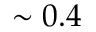Convert formula to latex. <formula><loc_0><loc_0><loc_500><loc_500>\sim 0 . 4</formula> 